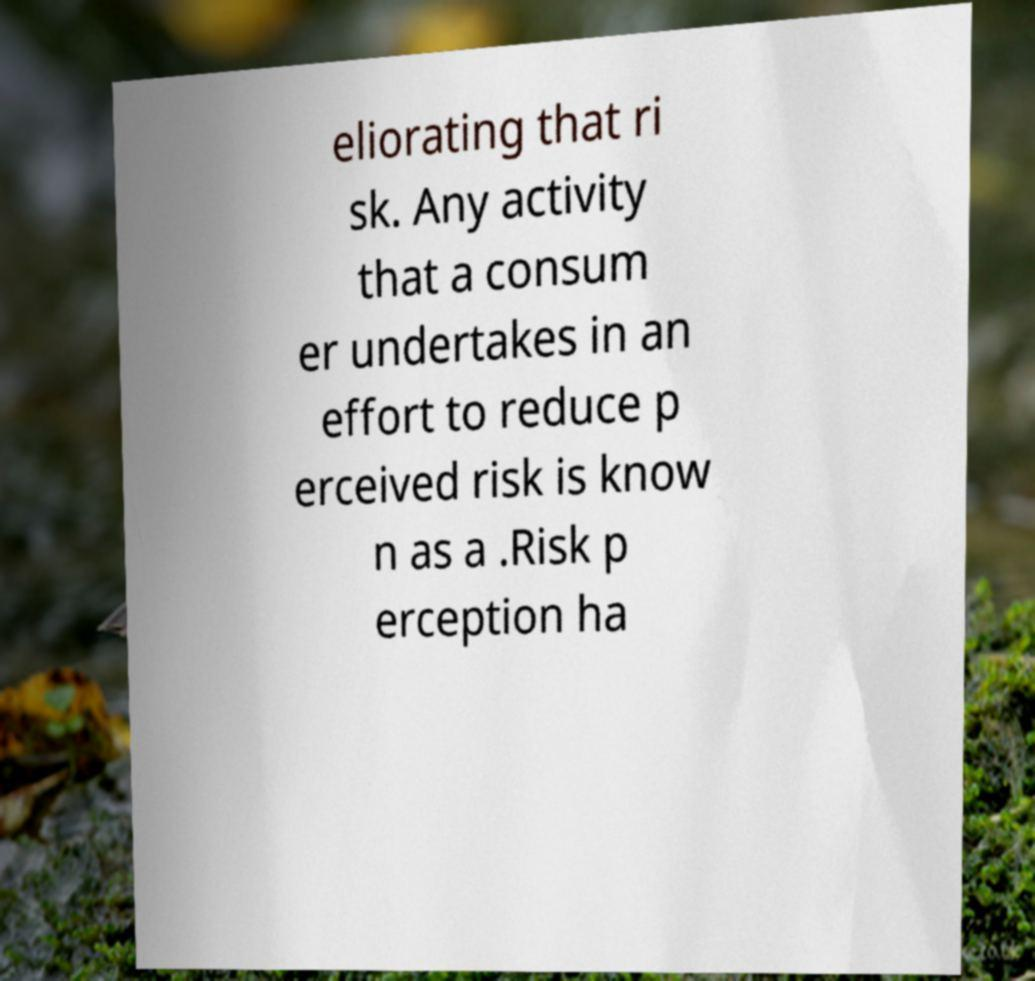For documentation purposes, I need the text within this image transcribed. Could you provide that? eliorating that ri sk. Any activity that a consum er undertakes in an effort to reduce p erceived risk is know n as a .Risk p erception ha 